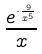<formula> <loc_0><loc_0><loc_500><loc_500>\frac { e ^ { \cdot \frac { 9 } { x ^ { 5 } } } } { x }</formula> 